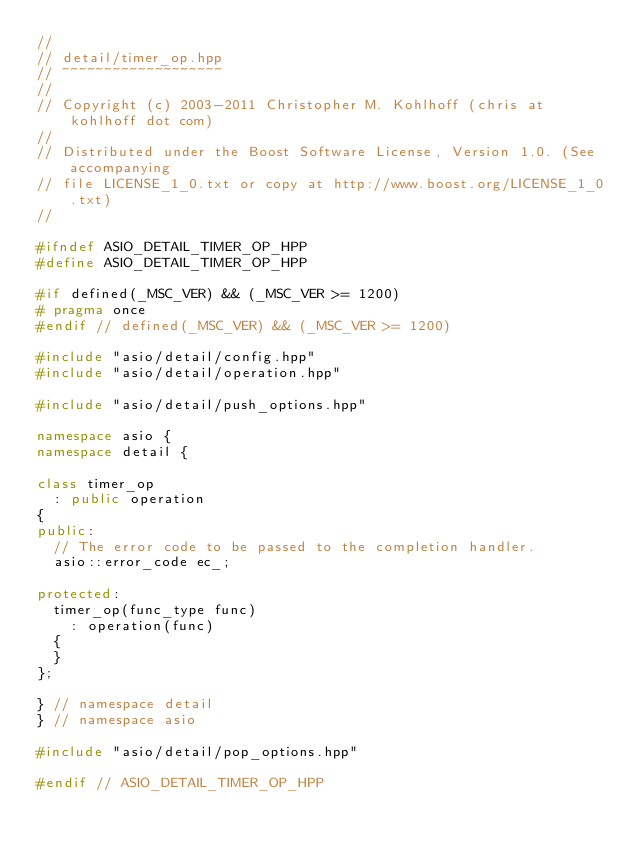<code> <loc_0><loc_0><loc_500><loc_500><_C++_>//
// detail/timer_op.hpp
// ~~~~~~~~~~~~~~~~~~~
//
// Copyright (c) 2003-2011 Christopher M. Kohlhoff (chris at kohlhoff dot com)
//
// Distributed under the Boost Software License, Version 1.0. (See accompanying
// file LICENSE_1_0.txt or copy at http://www.boost.org/LICENSE_1_0.txt)
//

#ifndef ASIO_DETAIL_TIMER_OP_HPP
#define ASIO_DETAIL_TIMER_OP_HPP

#if defined(_MSC_VER) && (_MSC_VER >= 1200)
# pragma once
#endif // defined(_MSC_VER) && (_MSC_VER >= 1200)

#include "asio/detail/config.hpp"
#include "asio/detail/operation.hpp"

#include "asio/detail/push_options.hpp"

namespace asio {
namespace detail {

class timer_op
  : public operation
{
public:
  // The error code to be passed to the completion handler.
  asio::error_code ec_;

protected:
  timer_op(func_type func)
    : operation(func)
  {
  }
};

} // namespace detail
} // namespace asio

#include "asio/detail/pop_options.hpp"

#endif // ASIO_DETAIL_TIMER_OP_HPP
</code> 